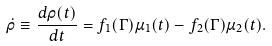Convert formula to latex. <formula><loc_0><loc_0><loc_500><loc_500>\dot { \rho } \equiv \frac { d \rho ( t ) } { d t } = f _ { 1 } ( \Gamma ) \mu _ { 1 } ( t ) - f _ { 2 } ( \Gamma ) \mu _ { 2 } ( t ) .</formula> 